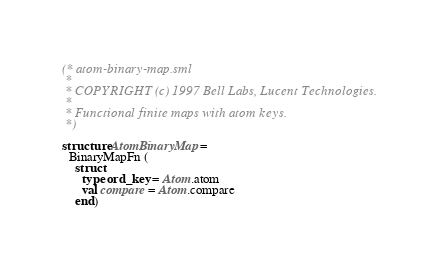Convert code to text. <code><loc_0><loc_0><loc_500><loc_500><_SML_>(* atom-binary-map.sml
 *
 * COPYRIGHT (c) 1997 Bell Labs, Lucent Technologies.
 *
 * Functional finite maps with atom keys.
 *)

structure AtomBinaryMap =
  BinaryMapFn (
    struct
      type ord_key = Atom.atom
      val compare = Atom.compare
    end)
</code> 